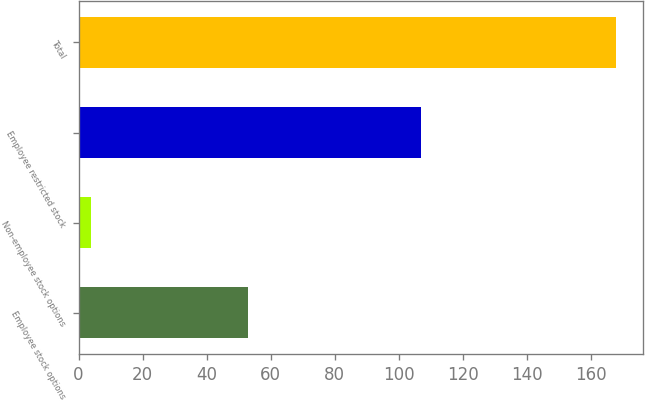<chart> <loc_0><loc_0><loc_500><loc_500><bar_chart><fcel>Employee stock options<fcel>Non-employee stock options<fcel>Employee restricted stock<fcel>Total<nl><fcel>53<fcel>4<fcel>107<fcel>168<nl></chart> 